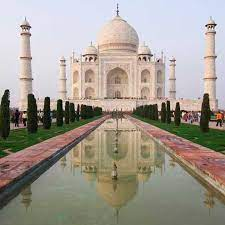What role do the gardens play in the overall aesthetic of the Taj Mahal? The gardens are an essential component of the Taj Mahal's design, rooted in the Persian concept of paradise gardens. They are symmetrically planned to embody a heavenly Eden as described in Islamic texts. The lush greenery and the orderly pathways encourage reflection and tranquility, framing the Taj Mahal and emphasizing its ethereal beauty. The alignment of the gardens with the central pool also reflects the site's architectural symmetry, adding to its visual harmony. 